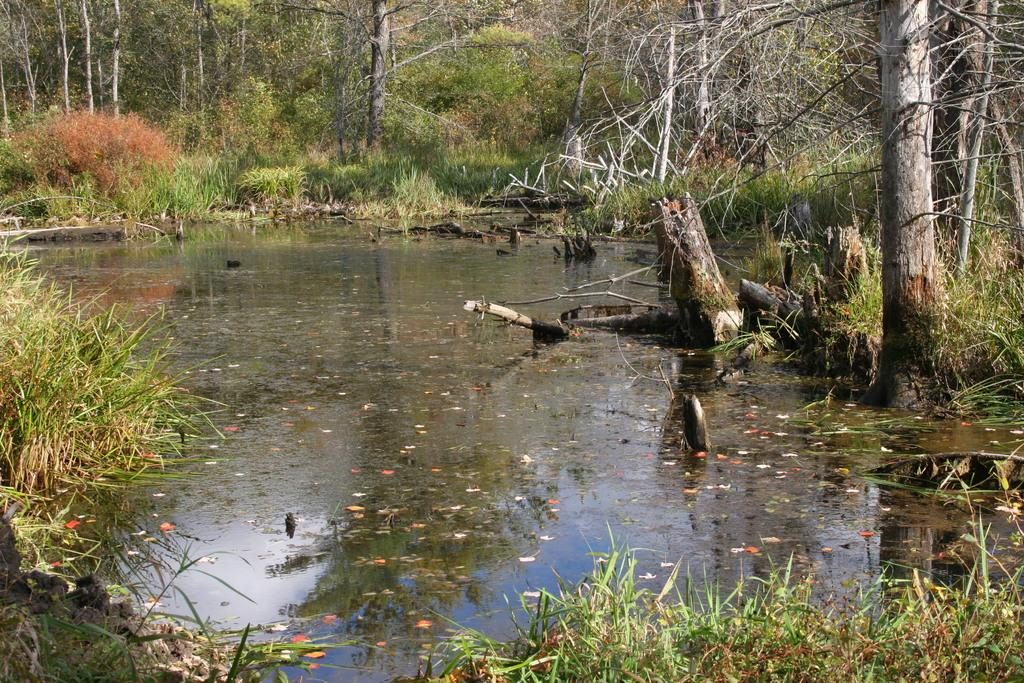What is the primary element in the image? The image consists of water. Where might this image have been taken? The image appears to be taken in a forest setting. What type of vegetation can be seen on the left side of the image? There is grass on the left side of the image. What can be seen in the background of the image? There are plants and trees in the background of the image. What type of nose can be seen on the tin cart in the image? There is no tin cart or nose present in the image. 